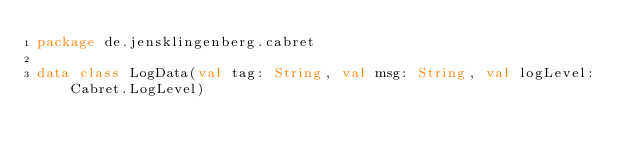<code> <loc_0><loc_0><loc_500><loc_500><_Kotlin_>package de.jensklingenberg.cabret

data class LogData(val tag: String, val msg: String, val logLevel: Cabret.LogLevel)</code> 